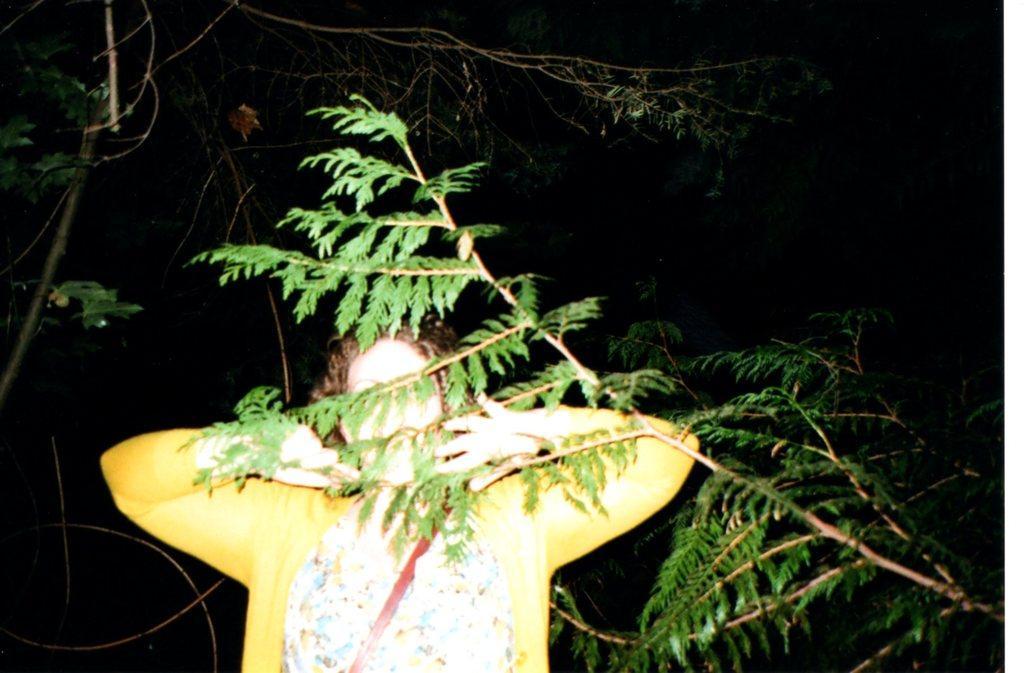How would you summarize this image in a sentence or two? In this picture, we see the woman in the yellow jacket is standing. In front of her, we see a tree. On the left side, we see a tree. In the background, it is black in color. This picture might be clicked in the dark. 